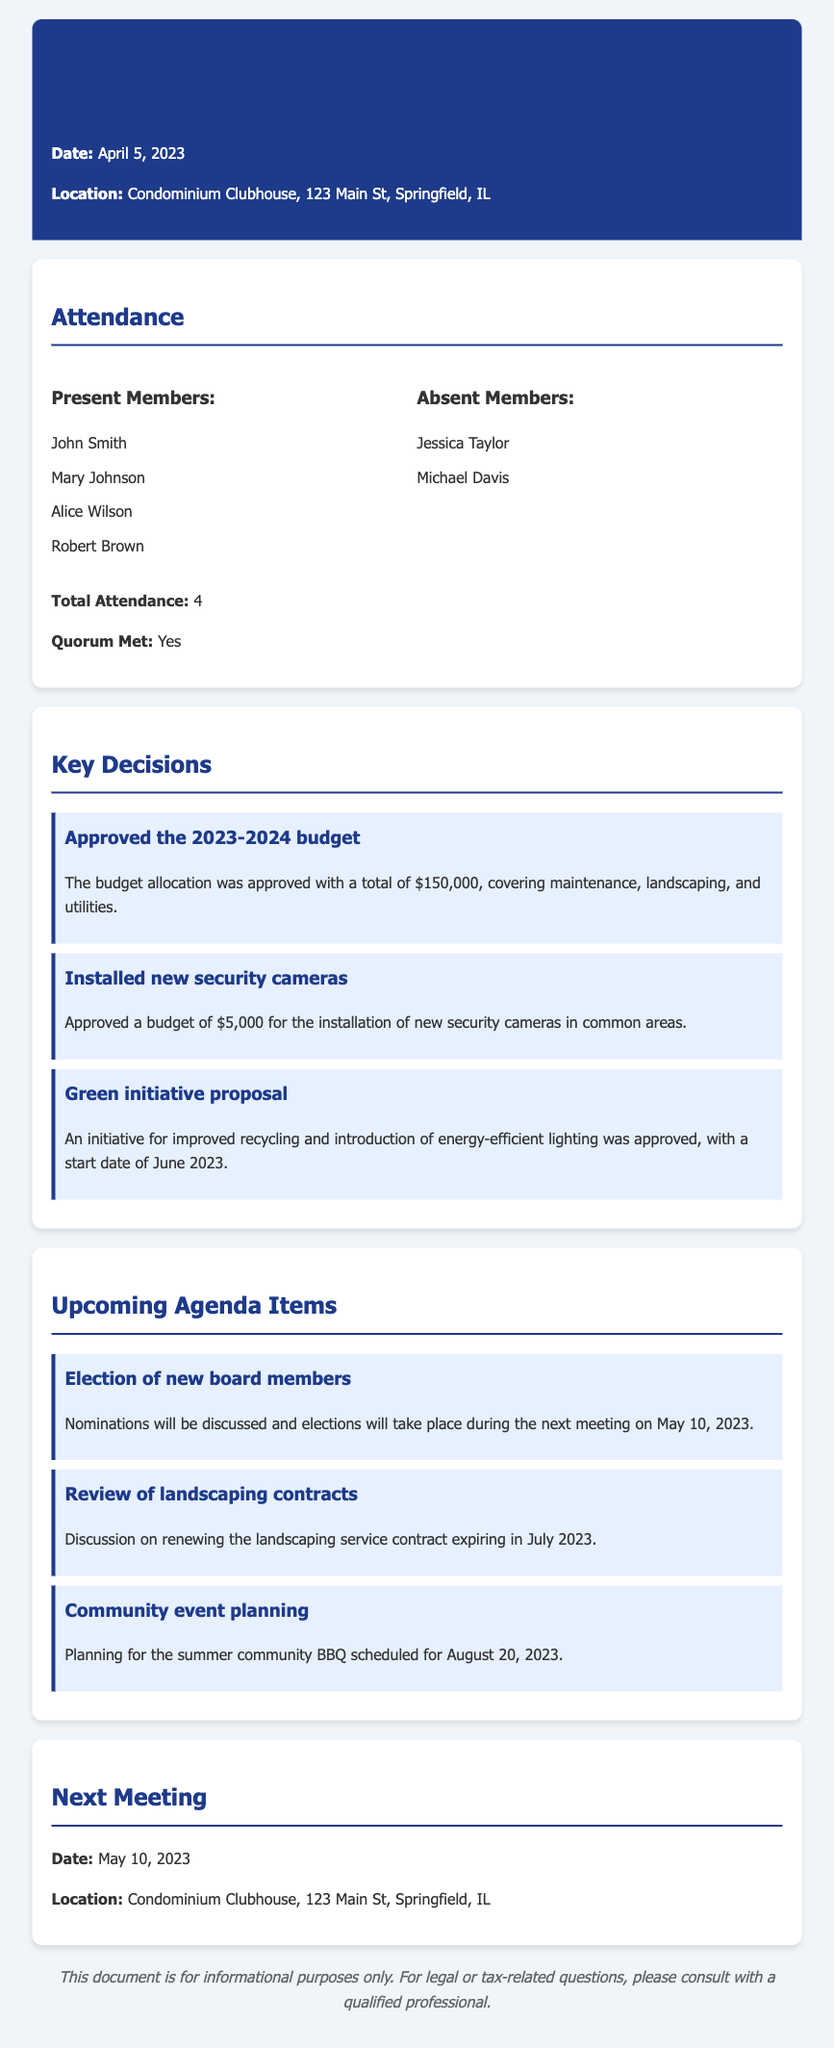What was the total budget approved? The total budget approved for 2023-2024 was mentioned in the decisions section of the document.
Answer: $150,000 Who were the absent members? The absent members are listed in the attendance section of the document.
Answer: Jessica Taylor, Michael Davis What is the date of the next meeting? The next meeting date is stated at the end of the document.
Answer: May 10, 2023 What initiative was approved regarding recycling? The document details a specific initiative about recycling in the key decisions section.
Answer: Green initiative proposal How many members were present at the meeting? The total number of members present is provided in the attendance section of the document.
Answer: 4 What was installed with a budget of $5,000? The decision regarding the budget allocation includes details about the installation mentioned in the document.
Answer: New security cameras When is the summer community BBQ scheduled? The planning details for the community event are found in the upcoming agenda items section.
Answer: August 20, 2023 What will be discussed during the next meeting? The upcoming agenda items list what topics will be discussed in the next meeting.
Answer: Election of new board members Was a quorum met during the meeting? The document states whether a quorum was achieved in the attendance section.
Answer: Yes 